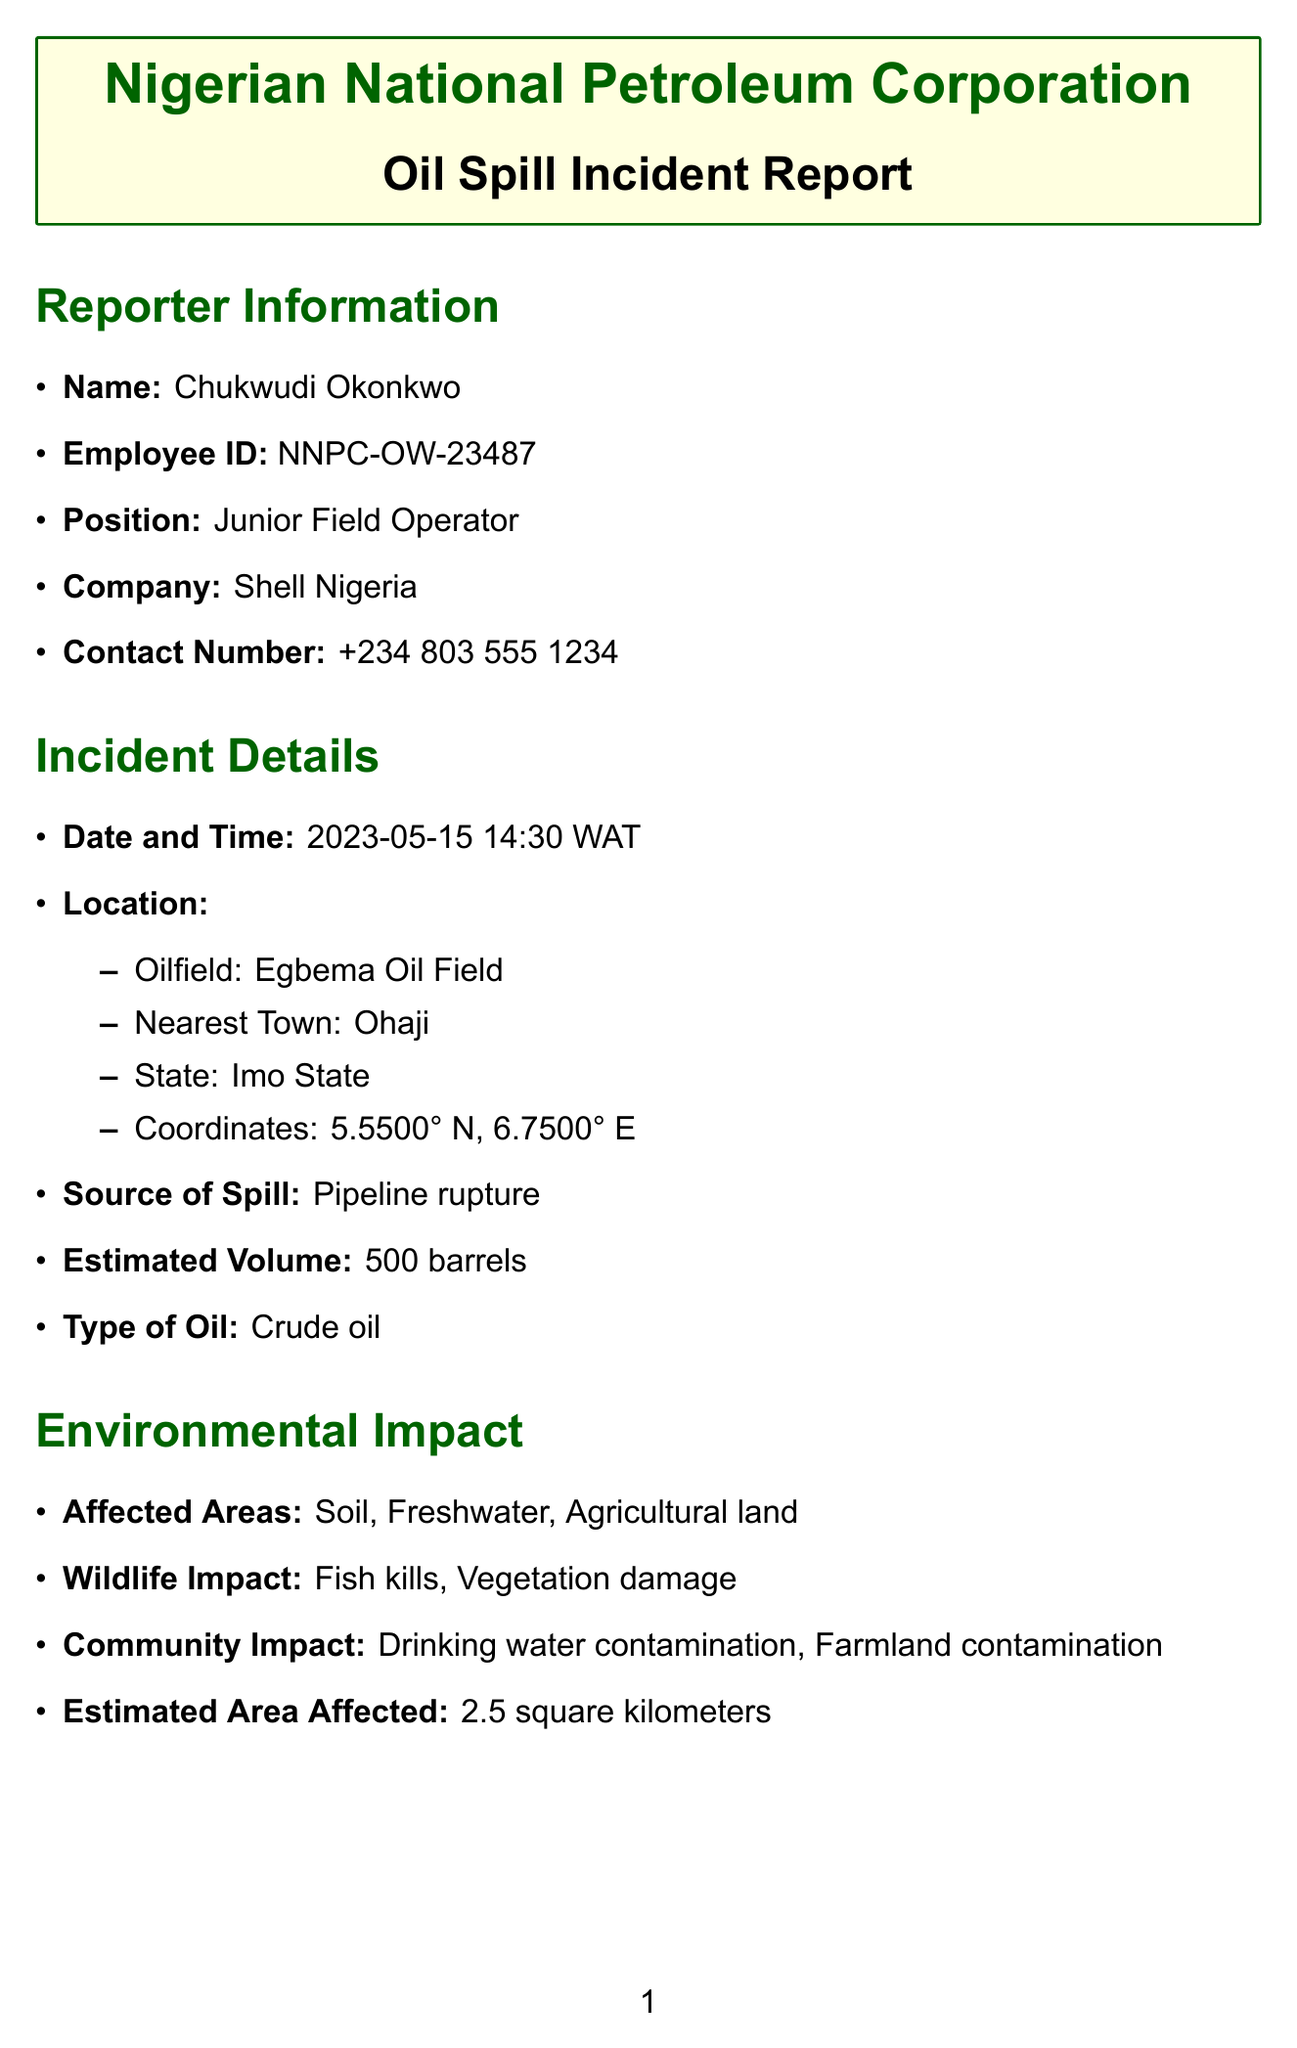what is the name of the reporter? The name of the reporter is listed in the reporter information section.
Answer: Chukwudi Okonkwo what is the estimated volume of oil spilled? The estimated volume can be found in the incident details section.
Answer: 500 barrels when did the oil spill incident occur? The date and time of the incident is specified in the incident details section.
Answer: 2023-05-15 14:30 WAT what type of oil was involved in the spill? The type of oil can be found in the incident details section under type of oil.
Answer: Crude oil which agency is listed first in the notification list? The first agency listed in the notification list is presented in order.
Answer: National Oil Spill Detection and Response Agency (NOSDRA) what are the immediate actions taken in response to the spill? The immediate actions taken are enumerated in the section dedicated to immediate actions.
Answer: Shut down pumps and close valves how many wildlife impacts are listed in the environmental impact section? The number of wildlife impacts is the count of items listed in that section.
Answer: 4 what is the estimated area affected by the spill? The estimated area affected is specified in the environmental impact section.
Answer: 2.5 square kilometers what is one of the follow-up actions mentioned? The follow-up actions can be found in the section dedicated to follow-up actions.
Answer: Conduct detailed environmental assessment 